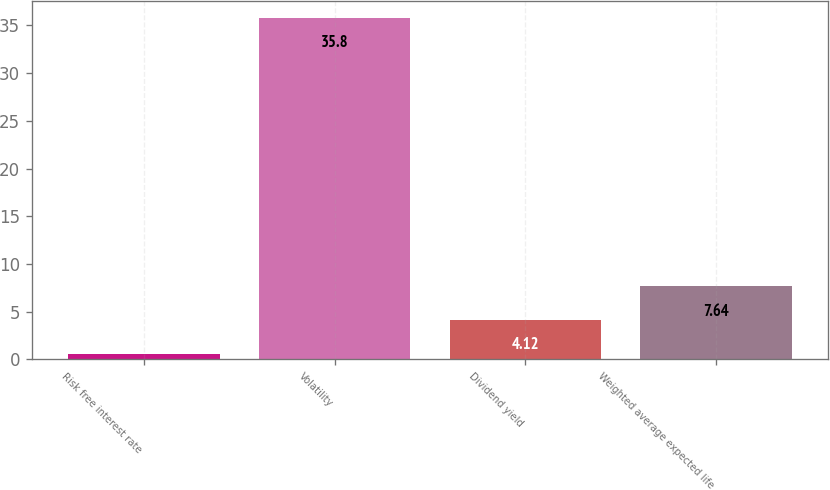Convert chart. <chart><loc_0><loc_0><loc_500><loc_500><bar_chart><fcel>Risk free interest rate<fcel>Volatility<fcel>Dividend yield<fcel>Weighted average expected life<nl><fcel>0.6<fcel>35.8<fcel>4.12<fcel>7.64<nl></chart> 